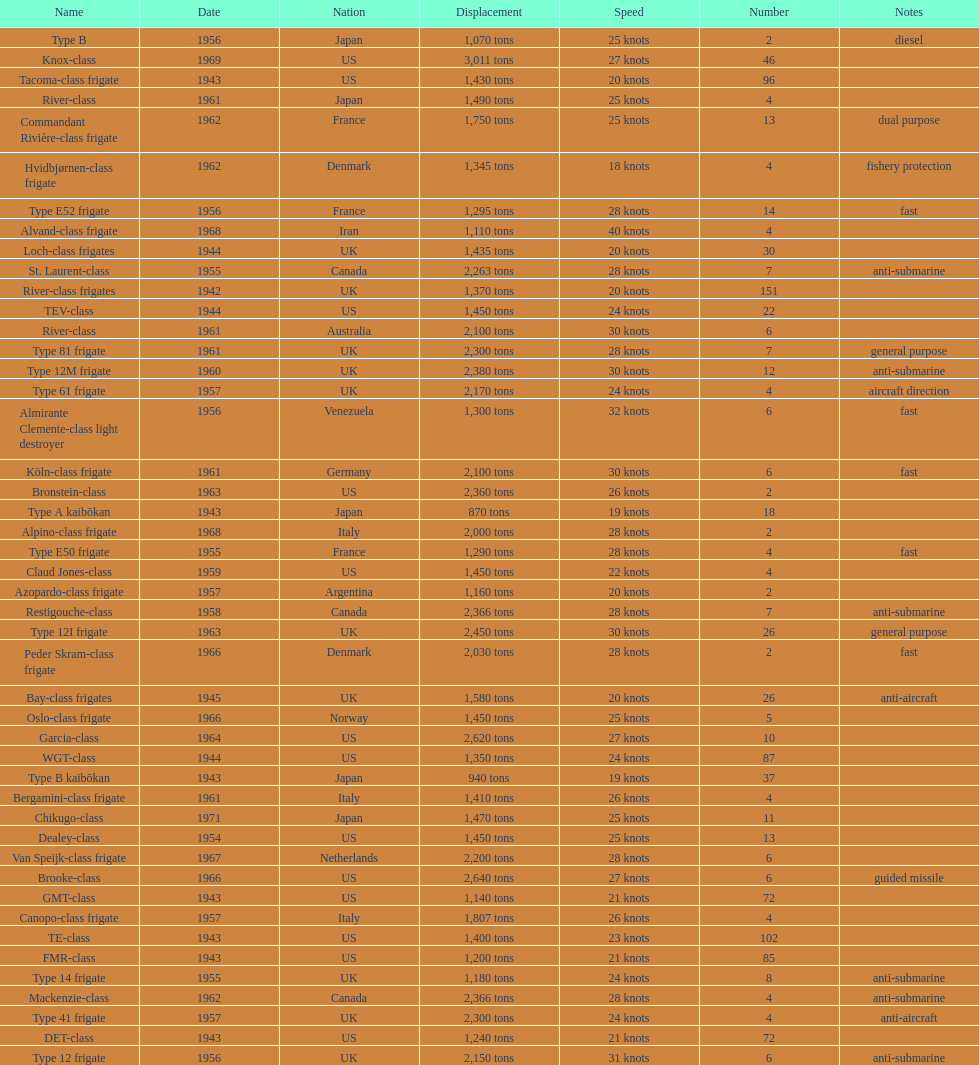Italy employed the alpino-class frigate in 196 28 knots. 